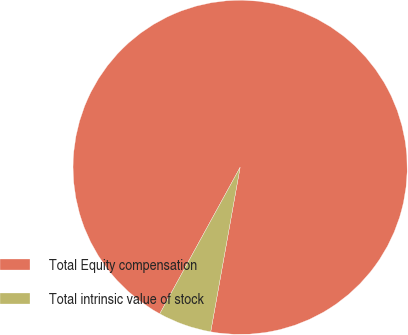Convert chart. <chart><loc_0><loc_0><loc_500><loc_500><pie_chart><fcel>Total Equity compensation<fcel>Total intrinsic value of stock<nl><fcel>94.83%<fcel>5.17%<nl></chart> 